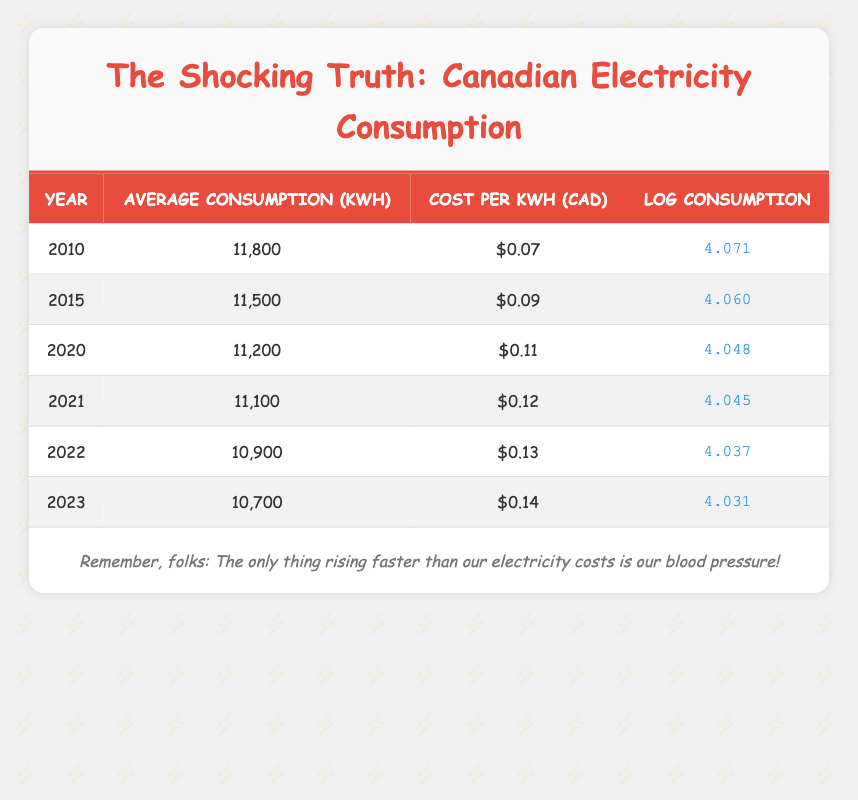What was the average household electricity consumption in 2020? Referring to the table, the average household electricity consumption for the year 2020 is listed as 11,200 kWh.
Answer: 11,200 kWh Which year had the highest cost per kWh? By examining the cost per kWh values in the table, the highest cost is found in 2023, which is $0.14.
Answer: $0.14 What is the difference in average consumption between 2010 and 2023? To find the difference, subtract the average consumption in 2023 (10,700 kWh) from 2010 (11,800 kWh): 11,800 - 10,700 = 1,100 kWh.
Answer: 1,100 kWh True or False: The average household electricity consumption has increased from 2010 to 2022. Checking the average consumption values from the table, 2010 shows 11,800 kWh and 2022 shows 10,900 kWh, indicating a decrease. Therefore, the statement is false.
Answer: False What is the average cost per kWh over the years from 2010 to 2023? Summing the cost per kWh from each year: 0.07 + 0.09 + 0.11 + 0.12 + 0.13 + 0.14 = 0.66. There are 6 years, so the average cost is 0.66 / 6 = 0.11.
Answer: 0.11 In which year did the average consumption drop below 11,000 kWh for the first time? Looking closely at the data, the average consumption falls below 11,000 kWh for the first time in 2022 when it is recorded at 10,900 kWh.
Answer: 2022 How much did the log consumption value decrease from 2010 to 2023? The log consumption value in 2010 is 4.071 and in 2023 it is 4.031. The decrease is calculated by subtracting: 4.071 - 4.031 = 0.040.
Answer: 0.040 Is the average consumption from 2021 higher than it was in 2022? Comparing the average consumption values, 2021 shows 11,100 kWh and 2022 shows 10,900 kWh, so 2021 is indeed higher. Therefore, the answer is yes.
Answer: Yes What is the total electricity cost for a household that consumed the average amount in 2022? The average household consumption in 2022 is 10,900 kWh, and the cost per kWh is $0.13. The total cost is calculated as 10,900 kWh * $0.13 = $1,417.00.
Answer: $1,417.00 